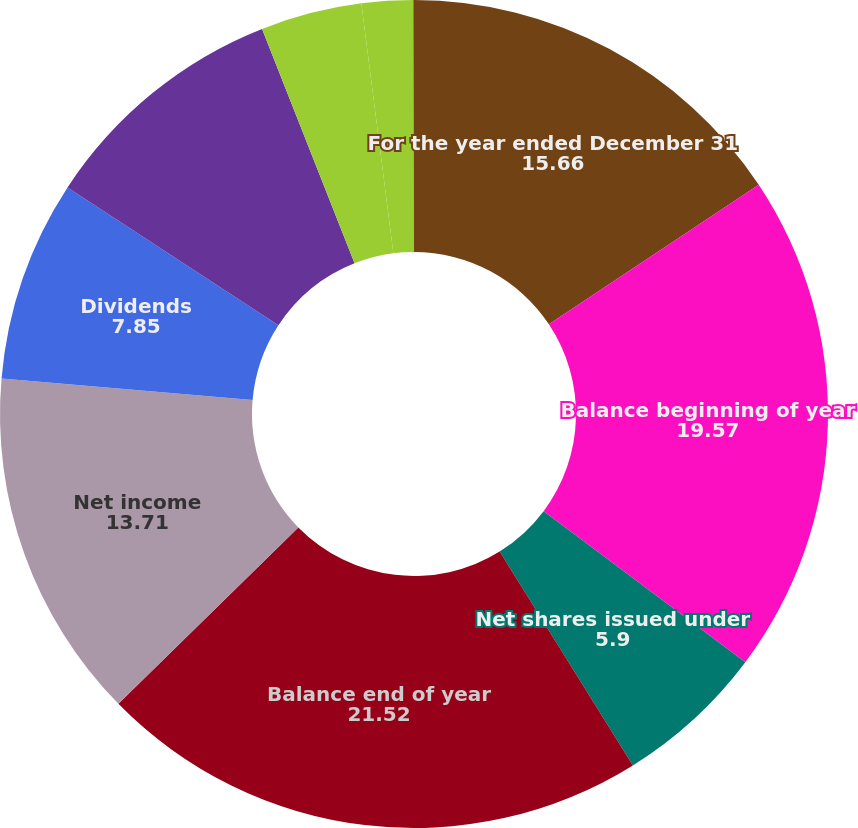Convert chart. <chart><loc_0><loc_0><loc_500><loc_500><pie_chart><fcel>For the year ended December 31<fcel>Balance beginning of year<fcel>Net shares issued under<fcel>Balance end of year<fcel>Net income<fcel>Dividends<fcel>Change in net unrealized gain<fcel>Netchange in unrealized<fcel>Netissuanceof restricted<fcel>Equity-based award<nl><fcel>15.66%<fcel>19.57%<fcel>5.9%<fcel>21.52%<fcel>13.71%<fcel>7.85%<fcel>9.8%<fcel>3.95%<fcel>1.99%<fcel>0.04%<nl></chart> 